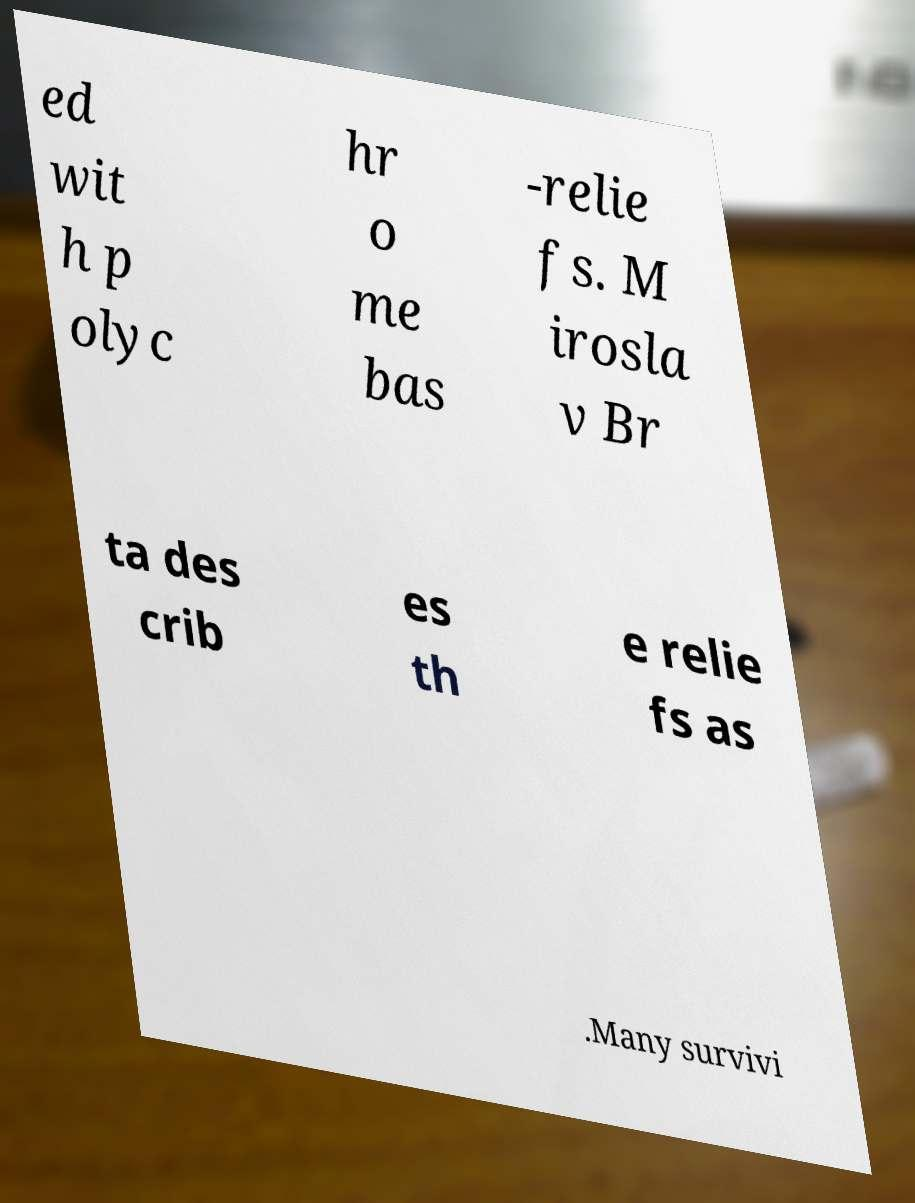Can you read and provide the text displayed in the image?This photo seems to have some interesting text. Can you extract and type it out for me? ed wit h p olyc hr o me bas -relie fs. M irosla v Br ta des crib es th e relie fs as .Many survivi 